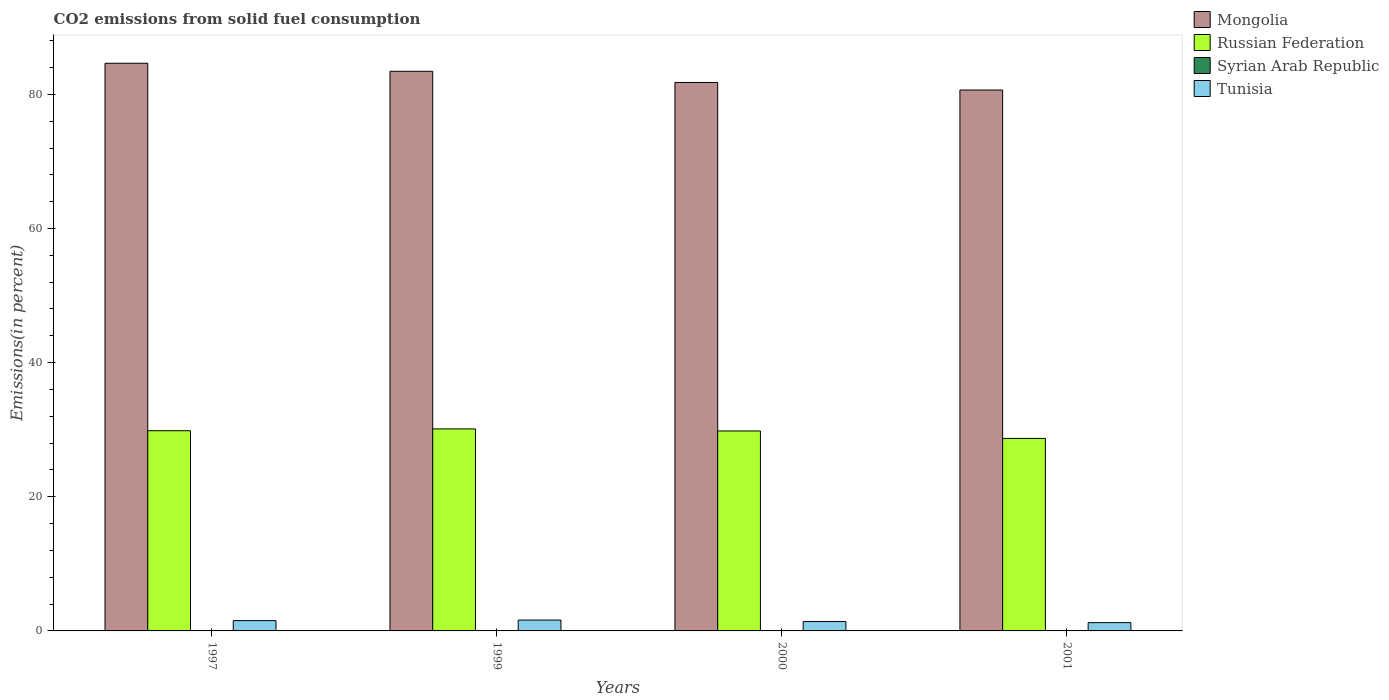How many different coloured bars are there?
Ensure brevity in your answer.  4. Are the number of bars per tick equal to the number of legend labels?
Your answer should be very brief. Yes. Are the number of bars on each tick of the X-axis equal?
Offer a terse response. Yes. How many bars are there on the 1st tick from the left?
Provide a succinct answer. 4. How many bars are there on the 3rd tick from the right?
Your answer should be very brief. 4. In how many cases, is the number of bars for a given year not equal to the number of legend labels?
Provide a succinct answer. 0. What is the total CO2 emitted in Syrian Arab Republic in 2000?
Make the answer very short. 0.02. Across all years, what is the maximum total CO2 emitted in Mongolia?
Give a very brief answer. 84.64. Across all years, what is the minimum total CO2 emitted in Tunisia?
Your answer should be very brief. 1.23. In which year was the total CO2 emitted in Syrian Arab Republic minimum?
Give a very brief answer. 1999. What is the total total CO2 emitted in Russian Federation in the graph?
Your answer should be compact. 118.49. What is the difference between the total CO2 emitted in Mongolia in 1997 and that in 1999?
Offer a very short reply. 1.19. What is the difference between the total CO2 emitted in Syrian Arab Republic in 2001 and the total CO2 emitted in Russian Federation in 1999?
Offer a terse response. -30.1. What is the average total CO2 emitted in Mongolia per year?
Ensure brevity in your answer.  82.63. In the year 2000, what is the difference between the total CO2 emitted in Tunisia and total CO2 emitted in Russian Federation?
Provide a short and direct response. -28.42. What is the ratio of the total CO2 emitted in Mongolia in 1999 to that in 2000?
Your response must be concise. 1.02. What is the difference between the highest and the second highest total CO2 emitted in Syrian Arab Republic?
Your answer should be compact. 0. What is the difference between the highest and the lowest total CO2 emitted in Russian Federation?
Offer a terse response. 1.42. Is the sum of the total CO2 emitted in Russian Federation in 1997 and 2000 greater than the maximum total CO2 emitted in Tunisia across all years?
Provide a short and direct response. Yes. Is it the case that in every year, the sum of the total CO2 emitted in Syrian Arab Republic and total CO2 emitted in Mongolia is greater than the sum of total CO2 emitted in Russian Federation and total CO2 emitted in Tunisia?
Offer a terse response. Yes. What does the 3rd bar from the left in 1997 represents?
Offer a terse response. Syrian Arab Republic. What does the 3rd bar from the right in 1999 represents?
Provide a short and direct response. Russian Federation. How many bars are there?
Provide a short and direct response. 16. How many years are there in the graph?
Provide a short and direct response. 4. What is the difference between two consecutive major ticks on the Y-axis?
Ensure brevity in your answer.  20. Are the values on the major ticks of Y-axis written in scientific E-notation?
Provide a short and direct response. No. Does the graph contain any zero values?
Offer a very short reply. No. How many legend labels are there?
Make the answer very short. 4. How are the legend labels stacked?
Make the answer very short. Vertical. What is the title of the graph?
Your response must be concise. CO2 emissions from solid fuel consumption. What is the label or title of the Y-axis?
Your answer should be very brief. Emissions(in percent). What is the Emissions(in percent) in Mongolia in 1997?
Your response must be concise. 84.64. What is the Emissions(in percent) in Russian Federation in 1997?
Your answer should be very brief. 29.85. What is the Emissions(in percent) of Syrian Arab Republic in 1997?
Make the answer very short. 0.03. What is the Emissions(in percent) in Tunisia in 1997?
Your answer should be compact. 1.54. What is the Emissions(in percent) in Mongolia in 1999?
Offer a very short reply. 83.45. What is the Emissions(in percent) in Russian Federation in 1999?
Give a very brief answer. 30.12. What is the Emissions(in percent) of Syrian Arab Republic in 1999?
Offer a terse response. 0.02. What is the Emissions(in percent) of Tunisia in 1999?
Your answer should be very brief. 1.62. What is the Emissions(in percent) in Mongolia in 2000?
Your answer should be compact. 81.78. What is the Emissions(in percent) of Russian Federation in 2000?
Provide a short and direct response. 29.81. What is the Emissions(in percent) in Syrian Arab Republic in 2000?
Make the answer very short. 0.02. What is the Emissions(in percent) of Tunisia in 2000?
Your answer should be very brief. 1.4. What is the Emissions(in percent) in Mongolia in 2001?
Your answer should be compact. 80.65. What is the Emissions(in percent) of Russian Federation in 2001?
Keep it short and to the point. 28.7. What is the Emissions(in percent) in Syrian Arab Republic in 2001?
Offer a very short reply. 0.02. What is the Emissions(in percent) in Tunisia in 2001?
Your answer should be very brief. 1.23. Across all years, what is the maximum Emissions(in percent) in Mongolia?
Provide a succinct answer. 84.64. Across all years, what is the maximum Emissions(in percent) of Russian Federation?
Ensure brevity in your answer.  30.12. Across all years, what is the maximum Emissions(in percent) of Syrian Arab Republic?
Ensure brevity in your answer.  0.03. Across all years, what is the maximum Emissions(in percent) in Tunisia?
Keep it short and to the point. 1.62. Across all years, what is the minimum Emissions(in percent) of Mongolia?
Provide a short and direct response. 80.65. Across all years, what is the minimum Emissions(in percent) of Russian Federation?
Give a very brief answer. 28.7. Across all years, what is the minimum Emissions(in percent) of Syrian Arab Republic?
Provide a short and direct response. 0.02. Across all years, what is the minimum Emissions(in percent) of Tunisia?
Your response must be concise. 1.23. What is the total Emissions(in percent) of Mongolia in the graph?
Provide a short and direct response. 330.52. What is the total Emissions(in percent) of Russian Federation in the graph?
Ensure brevity in your answer.  118.49. What is the total Emissions(in percent) in Syrian Arab Republic in the graph?
Your answer should be compact. 0.09. What is the total Emissions(in percent) in Tunisia in the graph?
Provide a short and direct response. 5.79. What is the difference between the Emissions(in percent) of Mongolia in 1997 and that in 1999?
Offer a terse response. 1.19. What is the difference between the Emissions(in percent) in Russian Federation in 1997 and that in 1999?
Provide a succinct answer. -0.27. What is the difference between the Emissions(in percent) of Syrian Arab Republic in 1997 and that in 1999?
Offer a terse response. 0.01. What is the difference between the Emissions(in percent) of Tunisia in 1997 and that in 1999?
Provide a succinct answer. -0.08. What is the difference between the Emissions(in percent) in Mongolia in 1997 and that in 2000?
Make the answer very short. 2.86. What is the difference between the Emissions(in percent) of Russian Federation in 1997 and that in 2000?
Give a very brief answer. 0.04. What is the difference between the Emissions(in percent) in Syrian Arab Republic in 1997 and that in 2000?
Your response must be concise. 0.01. What is the difference between the Emissions(in percent) of Tunisia in 1997 and that in 2000?
Provide a succinct answer. 0.14. What is the difference between the Emissions(in percent) in Mongolia in 1997 and that in 2001?
Provide a succinct answer. 3.99. What is the difference between the Emissions(in percent) of Russian Federation in 1997 and that in 2001?
Provide a succinct answer. 1.15. What is the difference between the Emissions(in percent) in Syrian Arab Republic in 1997 and that in 2001?
Your answer should be very brief. 0. What is the difference between the Emissions(in percent) in Tunisia in 1997 and that in 2001?
Offer a terse response. 0.3. What is the difference between the Emissions(in percent) of Mongolia in 1999 and that in 2000?
Your answer should be compact. 1.67. What is the difference between the Emissions(in percent) of Russian Federation in 1999 and that in 2000?
Offer a very short reply. 0.31. What is the difference between the Emissions(in percent) in Syrian Arab Republic in 1999 and that in 2000?
Provide a short and direct response. -0. What is the difference between the Emissions(in percent) of Tunisia in 1999 and that in 2000?
Provide a short and direct response. 0.22. What is the difference between the Emissions(in percent) in Mongolia in 1999 and that in 2001?
Your response must be concise. 2.8. What is the difference between the Emissions(in percent) of Russian Federation in 1999 and that in 2001?
Keep it short and to the point. 1.42. What is the difference between the Emissions(in percent) in Syrian Arab Republic in 1999 and that in 2001?
Your answer should be very brief. -0. What is the difference between the Emissions(in percent) in Tunisia in 1999 and that in 2001?
Your response must be concise. 0.39. What is the difference between the Emissions(in percent) in Mongolia in 2000 and that in 2001?
Give a very brief answer. 1.13. What is the difference between the Emissions(in percent) in Russian Federation in 2000 and that in 2001?
Your response must be concise. 1.11. What is the difference between the Emissions(in percent) in Syrian Arab Republic in 2000 and that in 2001?
Provide a succinct answer. -0. What is the difference between the Emissions(in percent) in Tunisia in 2000 and that in 2001?
Offer a terse response. 0.17. What is the difference between the Emissions(in percent) of Mongolia in 1997 and the Emissions(in percent) of Russian Federation in 1999?
Keep it short and to the point. 54.52. What is the difference between the Emissions(in percent) in Mongolia in 1997 and the Emissions(in percent) in Syrian Arab Republic in 1999?
Offer a very short reply. 84.62. What is the difference between the Emissions(in percent) of Mongolia in 1997 and the Emissions(in percent) of Tunisia in 1999?
Offer a very short reply. 83.02. What is the difference between the Emissions(in percent) of Russian Federation in 1997 and the Emissions(in percent) of Syrian Arab Republic in 1999?
Your answer should be very brief. 29.83. What is the difference between the Emissions(in percent) in Russian Federation in 1997 and the Emissions(in percent) in Tunisia in 1999?
Your answer should be compact. 28.23. What is the difference between the Emissions(in percent) of Syrian Arab Republic in 1997 and the Emissions(in percent) of Tunisia in 1999?
Offer a very short reply. -1.59. What is the difference between the Emissions(in percent) of Mongolia in 1997 and the Emissions(in percent) of Russian Federation in 2000?
Keep it short and to the point. 54.83. What is the difference between the Emissions(in percent) in Mongolia in 1997 and the Emissions(in percent) in Syrian Arab Republic in 2000?
Make the answer very short. 84.62. What is the difference between the Emissions(in percent) of Mongolia in 1997 and the Emissions(in percent) of Tunisia in 2000?
Offer a very short reply. 83.24. What is the difference between the Emissions(in percent) of Russian Federation in 1997 and the Emissions(in percent) of Syrian Arab Republic in 2000?
Offer a very short reply. 29.83. What is the difference between the Emissions(in percent) in Russian Federation in 1997 and the Emissions(in percent) in Tunisia in 2000?
Ensure brevity in your answer.  28.45. What is the difference between the Emissions(in percent) in Syrian Arab Republic in 1997 and the Emissions(in percent) in Tunisia in 2000?
Your answer should be very brief. -1.37. What is the difference between the Emissions(in percent) in Mongolia in 1997 and the Emissions(in percent) in Russian Federation in 2001?
Offer a terse response. 55.94. What is the difference between the Emissions(in percent) in Mongolia in 1997 and the Emissions(in percent) in Syrian Arab Republic in 2001?
Your response must be concise. 84.62. What is the difference between the Emissions(in percent) of Mongolia in 1997 and the Emissions(in percent) of Tunisia in 2001?
Keep it short and to the point. 83.41. What is the difference between the Emissions(in percent) in Russian Federation in 1997 and the Emissions(in percent) in Syrian Arab Republic in 2001?
Ensure brevity in your answer.  29.83. What is the difference between the Emissions(in percent) in Russian Federation in 1997 and the Emissions(in percent) in Tunisia in 2001?
Your answer should be very brief. 28.62. What is the difference between the Emissions(in percent) in Syrian Arab Republic in 1997 and the Emissions(in percent) in Tunisia in 2001?
Keep it short and to the point. -1.21. What is the difference between the Emissions(in percent) of Mongolia in 1999 and the Emissions(in percent) of Russian Federation in 2000?
Provide a short and direct response. 53.63. What is the difference between the Emissions(in percent) of Mongolia in 1999 and the Emissions(in percent) of Syrian Arab Republic in 2000?
Your answer should be very brief. 83.43. What is the difference between the Emissions(in percent) of Mongolia in 1999 and the Emissions(in percent) of Tunisia in 2000?
Offer a very short reply. 82.05. What is the difference between the Emissions(in percent) in Russian Federation in 1999 and the Emissions(in percent) in Syrian Arab Republic in 2000?
Offer a terse response. 30.1. What is the difference between the Emissions(in percent) of Russian Federation in 1999 and the Emissions(in percent) of Tunisia in 2000?
Your answer should be very brief. 28.72. What is the difference between the Emissions(in percent) in Syrian Arab Republic in 1999 and the Emissions(in percent) in Tunisia in 2000?
Your answer should be compact. -1.38. What is the difference between the Emissions(in percent) in Mongolia in 1999 and the Emissions(in percent) in Russian Federation in 2001?
Provide a short and direct response. 54.74. What is the difference between the Emissions(in percent) in Mongolia in 1999 and the Emissions(in percent) in Syrian Arab Republic in 2001?
Your response must be concise. 83.42. What is the difference between the Emissions(in percent) in Mongolia in 1999 and the Emissions(in percent) in Tunisia in 2001?
Keep it short and to the point. 82.21. What is the difference between the Emissions(in percent) in Russian Federation in 1999 and the Emissions(in percent) in Syrian Arab Republic in 2001?
Your answer should be compact. 30.1. What is the difference between the Emissions(in percent) of Russian Federation in 1999 and the Emissions(in percent) of Tunisia in 2001?
Your answer should be very brief. 28.89. What is the difference between the Emissions(in percent) of Syrian Arab Republic in 1999 and the Emissions(in percent) of Tunisia in 2001?
Provide a short and direct response. -1.21. What is the difference between the Emissions(in percent) in Mongolia in 2000 and the Emissions(in percent) in Russian Federation in 2001?
Provide a succinct answer. 53.08. What is the difference between the Emissions(in percent) of Mongolia in 2000 and the Emissions(in percent) of Syrian Arab Republic in 2001?
Give a very brief answer. 81.76. What is the difference between the Emissions(in percent) in Mongolia in 2000 and the Emissions(in percent) in Tunisia in 2001?
Your answer should be very brief. 80.55. What is the difference between the Emissions(in percent) of Russian Federation in 2000 and the Emissions(in percent) of Syrian Arab Republic in 2001?
Keep it short and to the point. 29.79. What is the difference between the Emissions(in percent) of Russian Federation in 2000 and the Emissions(in percent) of Tunisia in 2001?
Offer a very short reply. 28.58. What is the difference between the Emissions(in percent) of Syrian Arab Republic in 2000 and the Emissions(in percent) of Tunisia in 2001?
Offer a terse response. -1.21. What is the average Emissions(in percent) in Mongolia per year?
Provide a succinct answer. 82.63. What is the average Emissions(in percent) in Russian Federation per year?
Make the answer very short. 29.62. What is the average Emissions(in percent) in Syrian Arab Republic per year?
Offer a terse response. 0.02. What is the average Emissions(in percent) of Tunisia per year?
Provide a succinct answer. 1.45. In the year 1997, what is the difference between the Emissions(in percent) of Mongolia and Emissions(in percent) of Russian Federation?
Offer a terse response. 54.79. In the year 1997, what is the difference between the Emissions(in percent) of Mongolia and Emissions(in percent) of Syrian Arab Republic?
Provide a succinct answer. 84.61. In the year 1997, what is the difference between the Emissions(in percent) in Mongolia and Emissions(in percent) in Tunisia?
Provide a short and direct response. 83.1. In the year 1997, what is the difference between the Emissions(in percent) of Russian Federation and Emissions(in percent) of Syrian Arab Republic?
Provide a short and direct response. 29.83. In the year 1997, what is the difference between the Emissions(in percent) of Russian Federation and Emissions(in percent) of Tunisia?
Provide a short and direct response. 28.32. In the year 1997, what is the difference between the Emissions(in percent) in Syrian Arab Republic and Emissions(in percent) in Tunisia?
Your answer should be very brief. -1.51. In the year 1999, what is the difference between the Emissions(in percent) of Mongolia and Emissions(in percent) of Russian Federation?
Ensure brevity in your answer.  53.32. In the year 1999, what is the difference between the Emissions(in percent) of Mongolia and Emissions(in percent) of Syrian Arab Republic?
Your answer should be very brief. 83.43. In the year 1999, what is the difference between the Emissions(in percent) of Mongolia and Emissions(in percent) of Tunisia?
Provide a succinct answer. 81.83. In the year 1999, what is the difference between the Emissions(in percent) of Russian Federation and Emissions(in percent) of Syrian Arab Republic?
Give a very brief answer. 30.1. In the year 1999, what is the difference between the Emissions(in percent) of Russian Federation and Emissions(in percent) of Tunisia?
Your answer should be compact. 28.5. In the year 1999, what is the difference between the Emissions(in percent) in Syrian Arab Republic and Emissions(in percent) in Tunisia?
Offer a terse response. -1.6. In the year 2000, what is the difference between the Emissions(in percent) in Mongolia and Emissions(in percent) in Russian Federation?
Ensure brevity in your answer.  51.96. In the year 2000, what is the difference between the Emissions(in percent) of Mongolia and Emissions(in percent) of Syrian Arab Republic?
Provide a short and direct response. 81.76. In the year 2000, what is the difference between the Emissions(in percent) in Mongolia and Emissions(in percent) in Tunisia?
Offer a terse response. 80.38. In the year 2000, what is the difference between the Emissions(in percent) of Russian Federation and Emissions(in percent) of Syrian Arab Republic?
Ensure brevity in your answer.  29.79. In the year 2000, what is the difference between the Emissions(in percent) of Russian Federation and Emissions(in percent) of Tunisia?
Provide a succinct answer. 28.42. In the year 2000, what is the difference between the Emissions(in percent) in Syrian Arab Republic and Emissions(in percent) in Tunisia?
Keep it short and to the point. -1.38. In the year 2001, what is the difference between the Emissions(in percent) of Mongolia and Emissions(in percent) of Russian Federation?
Provide a succinct answer. 51.95. In the year 2001, what is the difference between the Emissions(in percent) in Mongolia and Emissions(in percent) in Syrian Arab Republic?
Your answer should be very brief. 80.63. In the year 2001, what is the difference between the Emissions(in percent) in Mongolia and Emissions(in percent) in Tunisia?
Your answer should be compact. 79.42. In the year 2001, what is the difference between the Emissions(in percent) of Russian Federation and Emissions(in percent) of Syrian Arab Republic?
Offer a terse response. 28.68. In the year 2001, what is the difference between the Emissions(in percent) in Russian Federation and Emissions(in percent) in Tunisia?
Your answer should be very brief. 27.47. In the year 2001, what is the difference between the Emissions(in percent) in Syrian Arab Republic and Emissions(in percent) in Tunisia?
Your response must be concise. -1.21. What is the ratio of the Emissions(in percent) of Mongolia in 1997 to that in 1999?
Your answer should be very brief. 1.01. What is the ratio of the Emissions(in percent) of Russian Federation in 1997 to that in 1999?
Provide a succinct answer. 0.99. What is the ratio of the Emissions(in percent) in Syrian Arab Republic in 1997 to that in 1999?
Provide a short and direct response. 1.28. What is the ratio of the Emissions(in percent) of Tunisia in 1997 to that in 1999?
Keep it short and to the point. 0.95. What is the ratio of the Emissions(in percent) in Mongolia in 1997 to that in 2000?
Provide a short and direct response. 1.03. What is the ratio of the Emissions(in percent) in Syrian Arab Republic in 1997 to that in 2000?
Make the answer very short. 1.25. What is the ratio of the Emissions(in percent) in Tunisia in 1997 to that in 2000?
Your answer should be very brief. 1.1. What is the ratio of the Emissions(in percent) in Mongolia in 1997 to that in 2001?
Provide a succinct answer. 1.05. What is the ratio of the Emissions(in percent) in Russian Federation in 1997 to that in 2001?
Ensure brevity in your answer.  1.04. What is the ratio of the Emissions(in percent) in Syrian Arab Republic in 1997 to that in 2001?
Your answer should be very brief. 1.19. What is the ratio of the Emissions(in percent) of Tunisia in 1997 to that in 2001?
Your answer should be very brief. 1.25. What is the ratio of the Emissions(in percent) of Mongolia in 1999 to that in 2000?
Your answer should be compact. 1.02. What is the ratio of the Emissions(in percent) of Russian Federation in 1999 to that in 2000?
Keep it short and to the point. 1.01. What is the ratio of the Emissions(in percent) in Syrian Arab Republic in 1999 to that in 2000?
Offer a very short reply. 0.97. What is the ratio of the Emissions(in percent) in Tunisia in 1999 to that in 2000?
Provide a succinct answer. 1.16. What is the ratio of the Emissions(in percent) in Mongolia in 1999 to that in 2001?
Make the answer very short. 1.03. What is the ratio of the Emissions(in percent) of Russian Federation in 1999 to that in 2001?
Give a very brief answer. 1.05. What is the ratio of the Emissions(in percent) in Syrian Arab Republic in 1999 to that in 2001?
Provide a succinct answer. 0.93. What is the ratio of the Emissions(in percent) in Tunisia in 1999 to that in 2001?
Your answer should be compact. 1.31. What is the ratio of the Emissions(in percent) of Mongolia in 2000 to that in 2001?
Keep it short and to the point. 1.01. What is the ratio of the Emissions(in percent) in Russian Federation in 2000 to that in 2001?
Give a very brief answer. 1.04. What is the ratio of the Emissions(in percent) of Syrian Arab Republic in 2000 to that in 2001?
Give a very brief answer. 0.96. What is the ratio of the Emissions(in percent) of Tunisia in 2000 to that in 2001?
Your response must be concise. 1.13. What is the difference between the highest and the second highest Emissions(in percent) of Mongolia?
Give a very brief answer. 1.19. What is the difference between the highest and the second highest Emissions(in percent) of Russian Federation?
Your response must be concise. 0.27. What is the difference between the highest and the second highest Emissions(in percent) of Syrian Arab Republic?
Make the answer very short. 0. What is the difference between the highest and the second highest Emissions(in percent) in Tunisia?
Offer a terse response. 0.08. What is the difference between the highest and the lowest Emissions(in percent) of Mongolia?
Provide a short and direct response. 3.99. What is the difference between the highest and the lowest Emissions(in percent) of Russian Federation?
Provide a short and direct response. 1.42. What is the difference between the highest and the lowest Emissions(in percent) of Syrian Arab Republic?
Give a very brief answer. 0.01. What is the difference between the highest and the lowest Emissions(in percent) of Tunisia?
Your answer should be compact. 0.39. 